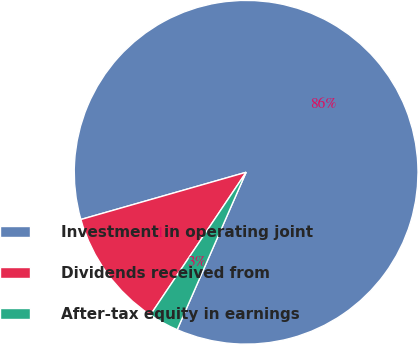Convert chart to OTSL. <chart><loc_0><loc_0><loc_500><loc_500><pie_chart><fcel>Investment in operating joint<fcel>Dividends received from<fcel>After-tax equity in earnings<nl><fcel>86.0%<fcel>11.16%<fcel>2.84%<nl></chart> 